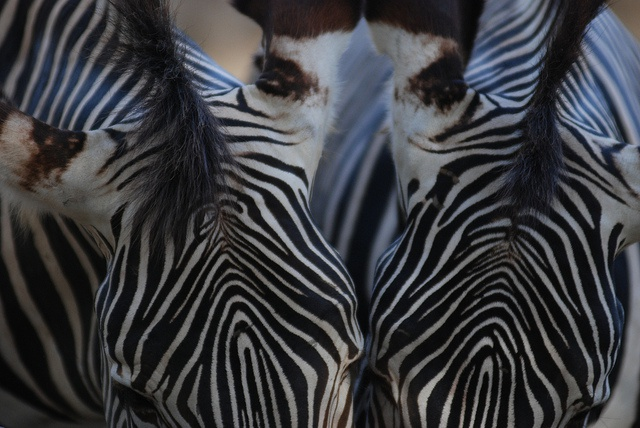Describe the objects in this image and their specific colors. I can see zebra in black, gray, and darkgray tones and zebra in black and gray tones in this image. 